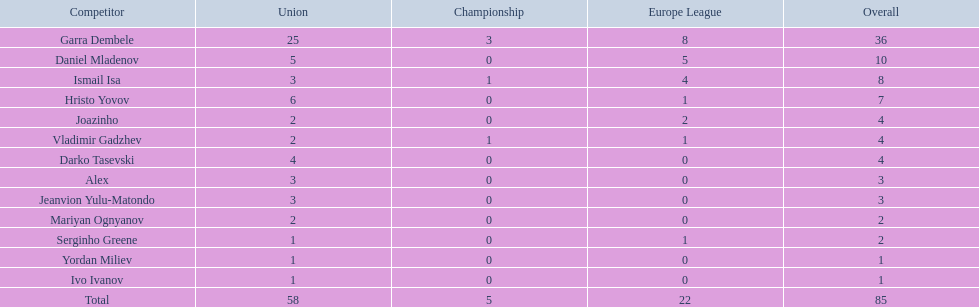Could you parse the entire table? {'header': ['Competitor', 'Union', 'Championship', 'Europe League', 'Overall'], 'rows': [['Garra Dembele', '25', '3', '8', '36'], ['Daniel Mladenov', '5', '0', '5', '10'], ['Ismail Isa', '3', '1', '4', '8'], ['Hristo Yovov', '6', '0', '1', '7'], ['Joazinho', '2', '0', '2', '4'], ['Vladimir Gadzhev', '2', '1', '1', '4'], ['Darko Tasevski', '4', '0', '0', '4'], ['Alex', '3', '0', '0', '3'], ['Jeanvion Yulu-Matondo', '3', '0', '0', '3'], ['Mariyan Ognyanov', '2', '0', '0', '2'], ['Serginho Greene', '1', '0', '1', '2'], ['Yordan Miliev', '1', '0', '0', '1'], ['Ivo Ivanov', '1', '0', '0', '1'], ['Total', '58', '5', '22', '85']]} Which players managed to score just a single goal? Serginho Greene, Yordan Miliev, Ivo Ivanov. 